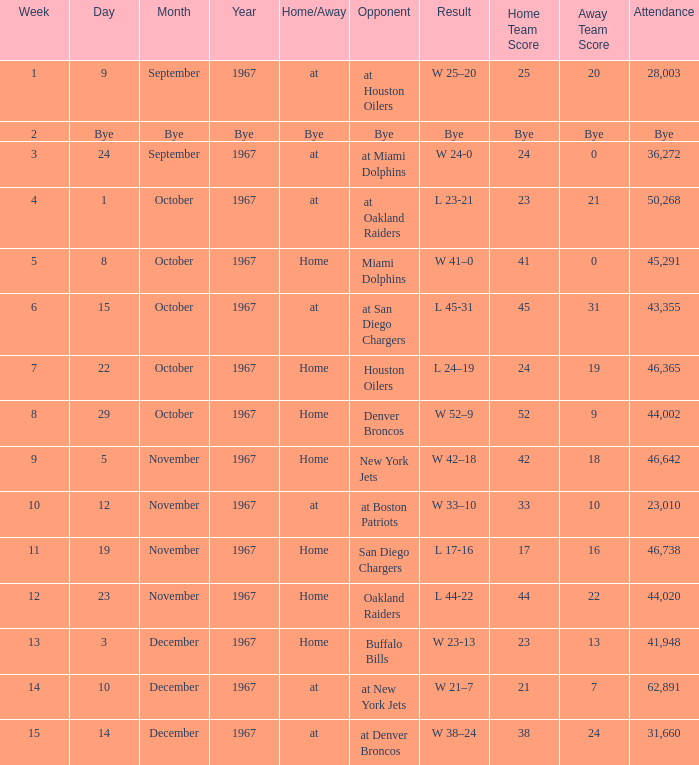Which week was the game on December 14, 1967? 15.0. 